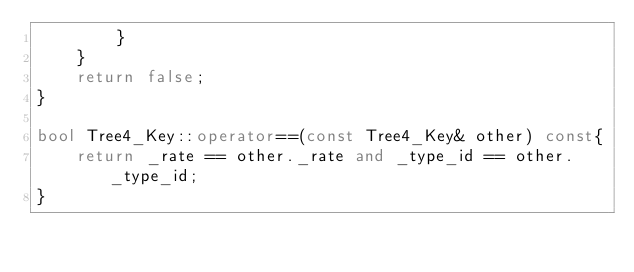Convert code to text. <code><loc_0><loc_0><loc_500><loc_500><_C++_>        }
    }
    return false;
}

bool Tree4_Key::operator==(const Tree4_Key& other) const{
    return _rate == other._rate and _type_id == other._type_id;
}




</code> 